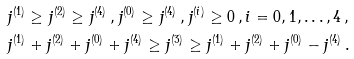Convert formula to latex. <formula><loc_0><loc_0><loc_500><loc_500>& j ^ { ( 1 ) } \geq j ^ { ( 2 ) } \geq j ^ { ( 4 ) } \, , j ^ { ( 0 ) } \geq j ^ { ( 4 ) } \, , j ^ { ( i ) } \geq 0 \, , i = 0 , 1 , \dots , 4 \, , \\ & j ^ { ( 1 ) } + j ^ { ( 2 ) } + j ^ { ( 0 ) } + j ^ { ( 4 ) } \geq j ^ { ( 3 ) } \geq j ^ { ( 1 ) } + j ^ { ( 2 ) } + j ^ { ( 0 ) } - j ^ { ( 4 ) } \, .</formula> 